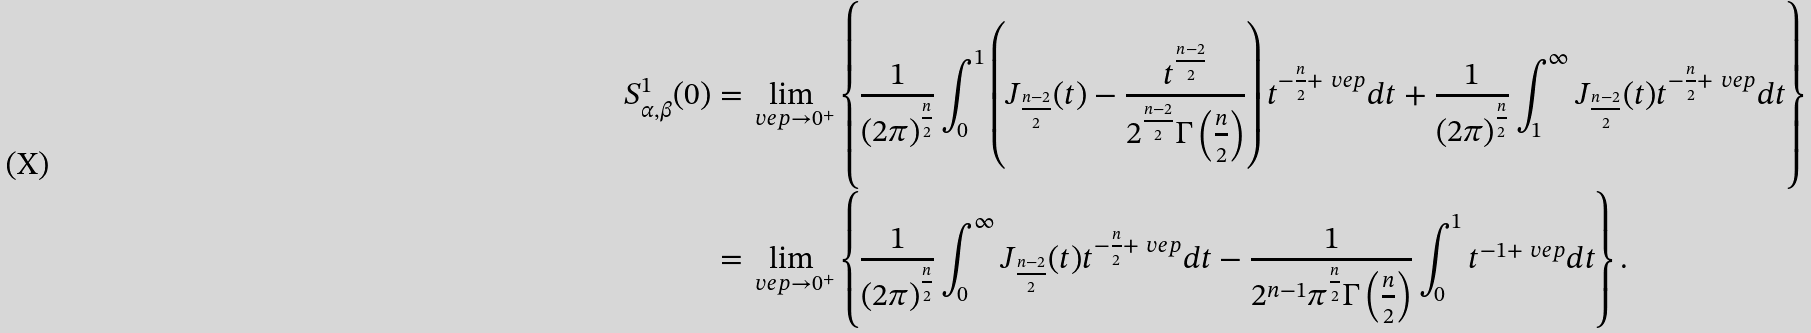<formula> <loc_0><loc_0><loc_500><loc_500>S _ { \alpha , \beta } ^ { 1 } ( 0 ) = & \lim _ { \ v e p \rightarrow 0 ^ { + } } \left \{ \frac { 1 } { ( 2 \pi ) ^ { \frac { n } { 2 } } } \int _ { 0 } ^ { 1 } \left ( J _ { \frac { n - 2 } { 2 } } ( t ) - \frac { t ^ { \frac { n - 2 } { 2 } } } { 2 ^ { \frac { n - 2 } { 2 } } \Gamma \left ( \frac { n } { 2 } \right ) } \right ) t ^ { - \frac { n } { 2 } + \ v e p } d t + \frac { 1 } { ( 2 \pi ) ^ { \frac { n } { 2 } } } \int _ { 1 } ^ { \infty } J _ { \frac { n - 2 } { 2 } } ( t ) t ^ { - \frac { n } { 2 } + \ v e p } d t \right \} \\ = & \lim _ { \ v e p \rightarrow 0 ^ { + } } \left \{ \frac { 1 } { ( 2 \pi ) ^ { \frac { n } { 2 } } } \int _ { 0 } ^ { \infty } J _ { \frac { n - 2 } { 2 } } ( t ) t ^ { - \frac { n } { 2 } + \ v e p } d t - \frac { 1 } { 2 ^ { n - 1 } \pi ^ { \frac { n } { 2 } } \Gamma \left ( \frac { n } { 2 } \right ) } \int _ { 0 } ^ { 1 } t ^ { - 1 + \ v e p } d t \right \} .</formula> 